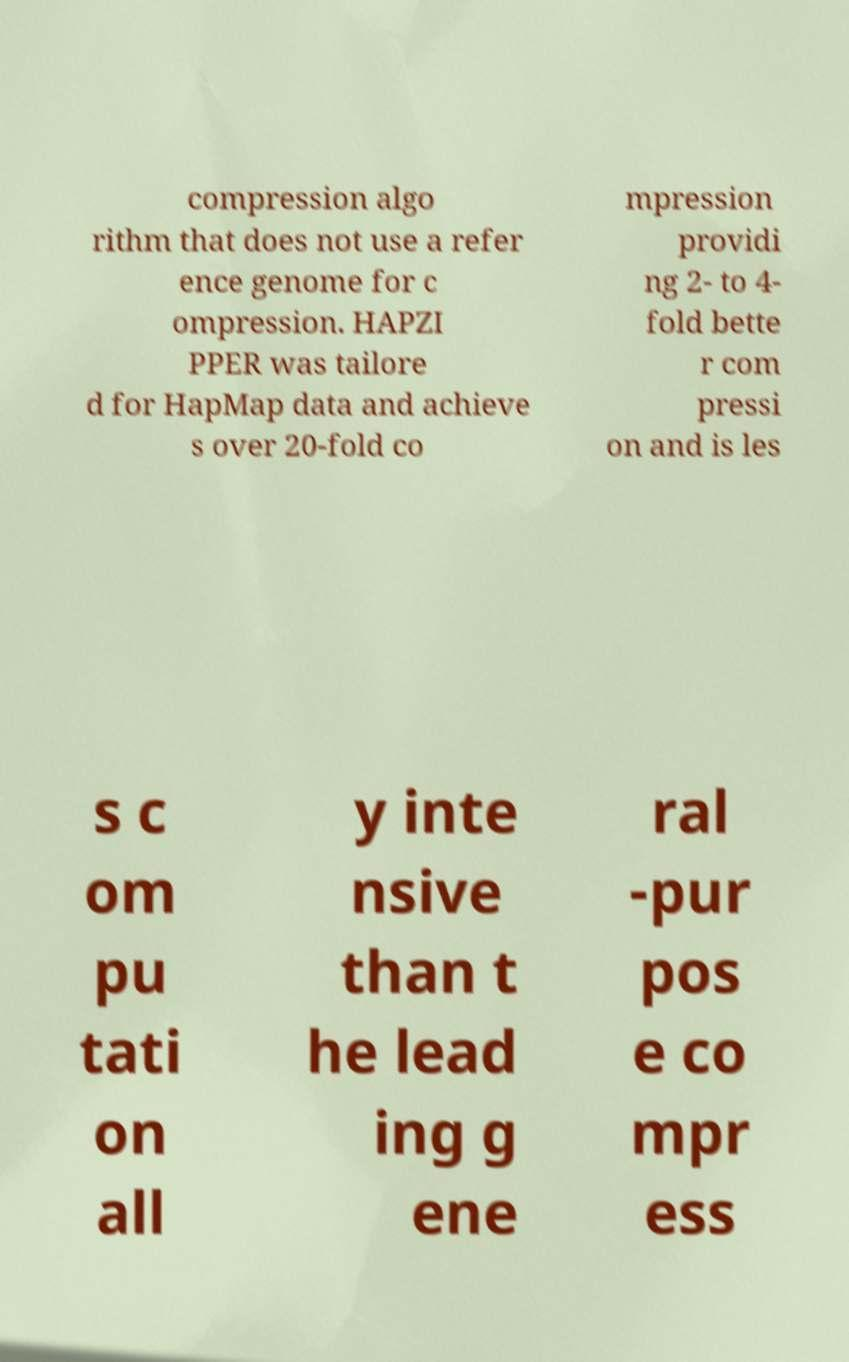I need the written content from this picture converted into text. Can you do that? compression algo rithm that does not use a refer ence genome for c ompression. HAPZI PPER was tailore d for HapMap data and achieve s over 20-fold co mpression providi ng 2- to 4- fold bette r com pressi on and is les s c om pu tati on all y inte nsive than t he lead ing g ene ral -pur pos e co mpr ess 